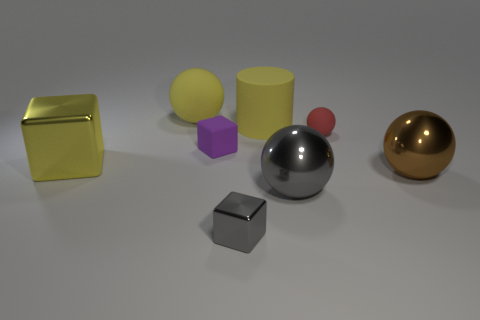Subtract all cylinders. How many objects are left? 7 Add 1 large gray objects. How many objects exist? 9 Subtract all yellow spheres. How many spheres are left? 3 Subtract all matte blocks. How many blocks are left? 2 Subtract 0 green balls. How many objects are left? 8 Subtract 1 cylinders. How many cylinders are left? 0 Subtract all purple blocks. Subtract all cyan cylinders. How many blocks are left? 2 Subtract all green balls. How many blue cylinders are left? 0 Subtract all big brown things. Subtract all small yellow matte blocks. How many objects are left? 7 Add 3 large yellow metal cubes. How many large yellow metal cubes are left? 4 